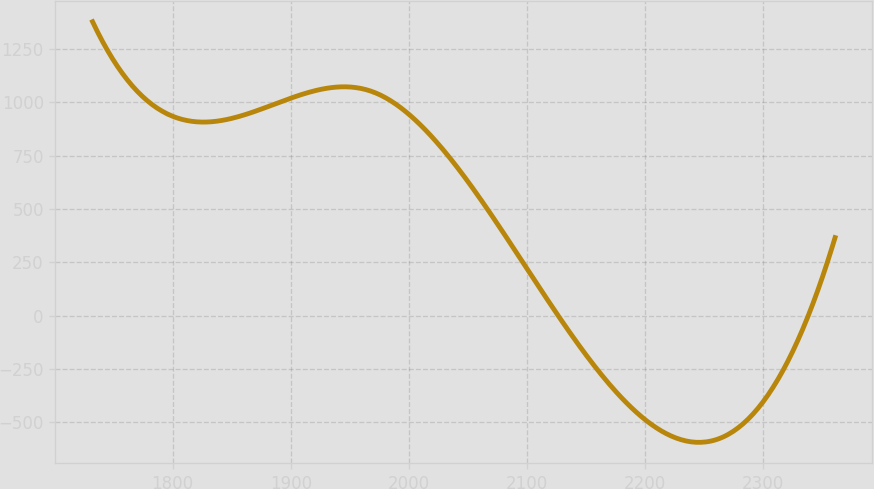Convert chart to OTSL. <chart><loc_0><loc_0><loc_500><loc_500><line_chart><ecel><fcel>Unnamed: 1<nl><fcel>1732.27<fcel>1377.3<nl><fcel>1795.12<fcel>946.6<nl><fcel>1970.06<fcel>1047.73<nl><fcel>2032.91<fcel>751.65<nl><fcel>2360.8<fcel>365.97<nl></chart> 